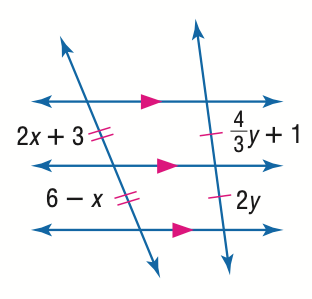Answer the mathemtical geometry problem and directly provide the correct option letter.
Question: Find y.
Choices: A: 1.5 B: 2 C: 2.5 D: 3 A 